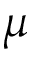<formula> <loc_0><loc_0><loc_500><loc_500>\mu</formula> 